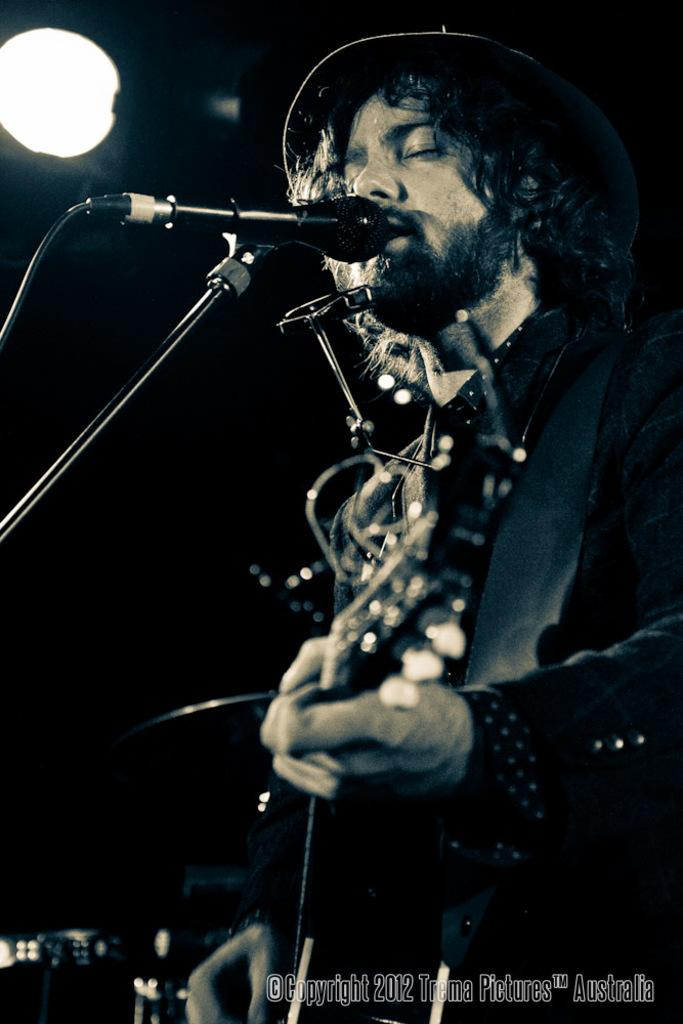What is the man in the image doing? The man is singing on a mic and playing a guitar. Can you describe the lighting in the image? There is a light in the top left corner of the image. Is there any text or logo visible in the image? Yes, there is a watermark in the bottom right corner of the image. Can you see a toad sitting on a chair next to the man in the image? No, there is no toad or chair present in the image. 